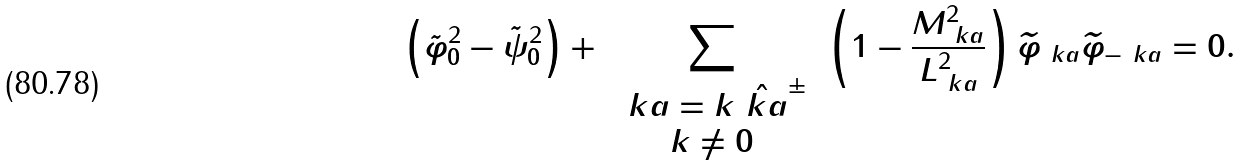Convert formula to latex. <formula><loc_0><loc_0><loc_500><loc_500>\left ( \tilde { \varphi } ^ { 2 } _ { 0 } - \tilde { \psi } ^ { 2 } _ { 0 } \right ) + \, \sum _ { \begin{array} { c } \ k a = k \hat { \ k a } ^ { \pm } \\ k \neq 0 \end{array} } \, \left ( 1 - \frac { M _ { \ k a } ^ { 2 } } { L _ { \ k a } ^ { 2 } } \right ) \widetilde { \varphi } _ { \ k a } \widetilde { \varphi } _ { - \ k a } = 0 .</formula> 